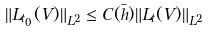<formula> <loc_0><loc_0><loc_500><loc_500>\| L _ { t _ { 0 } } ( V ) \| _ { L ^ { 2 } } & \leq C ( \bar { h } ) \| L _ { t } ( V ) \| _ { L ^ { 2 } }</formula> 